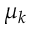<formula> <loc_0><loc_0><loc_500><loc_500>\mu _ { k }</formula> 